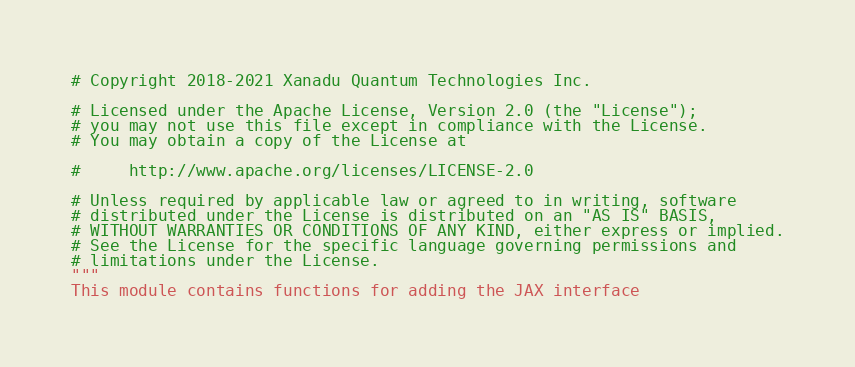Convert code to text. <code><loc_0><loc_0><loc_500><loc_500><_Python_># Copyright 2018-2021 Xanadu Quantum Technologies Inc.

# Licensed under the Apache License, Version 2.0 (the "License");
# you may not use this file except in compliance with the License.
# You may obtain a copy of the License at

#     http://www.apache.org/licenses/LICENSE-2.0

# Unless required by applicable law or agreed to in writing, software
# distributed under the License is distributed on an "AS IS" BASIS,
# WITHOUT WARRANTIES OR CONDITIONS OF ANY KIND, either express or implied.
# See the License for the specific language governing permissions and
# limitations under the License.
"""
This module contains functions for adding the JAX interface</code> 